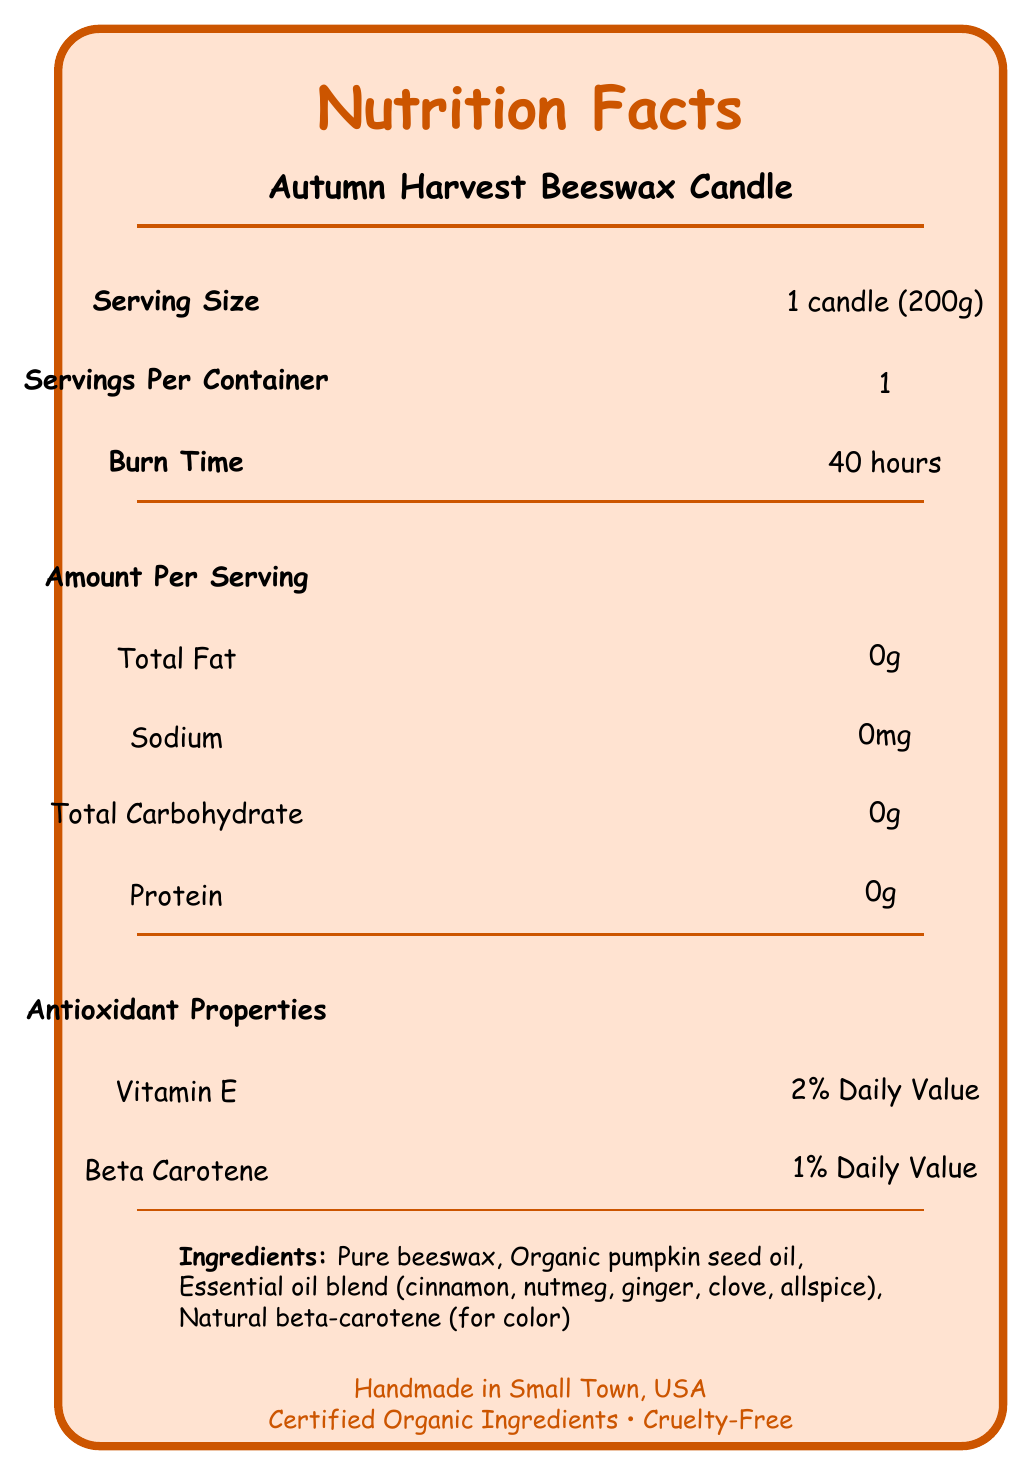What is the burn time of the Autumn Harvest Beeswax Candle? The document explicitly mentions the burn time as 40 hours in the section under Burn Time.
Answer: 40 hours How many servings are there per container? The document clearly states "Servings Per Container: 1."
Answer: 1 List the ingredients of the Autumn Harvest Beeswax Candle. The ingredients are listed at the bottom of the document under Ingredients.
Answer: Pure beeswax, Organic pumpkin seed oil, Essential oil blend (cinnamon, nutmeg, ginger, clove, allspice), Natural beta-carotene (for color) Which antioxidants are present in this candle, and what are their daily values? The Antioxidant Properties section lists Vitamin E and Beta Carotene with their respective daily values.
Answer: Vitamin E: 2% Daily Value, Beta Carotene: 1% Daily Value Does the candle contain any proteins? The Amount Per Serving section lists the protein content as 0g.
Answer: No What are the eco-friendly features of the candle? The features section mentions these specific eco-friendly attributes.
Answer: 100% natural ingredients, Biodegradable, Sustainably sourced beeswax Multiple-choice: What is the serving size?
A. 50g
B. 100g
C. 150g
D. 200g The Serving Size mentioned is "1 candle (200g)."
Answer: D Multiple-choice: Which of the following is not listed as an ingredient in the Autumn Harvest Beeswax Candle?
A. Cinnamon
B. Beeswax
C. Lavender
D. Nutmeg The ingredient list does not include Lavender; it lists Cinnamon, Beeswax, and Nutmeg.
Answer: C Yes/No: Is the candle certified organic? The document states that the candle contains Certified Organic Ingredients.
Answer: Yes Summary: Describe the main idea of the document. The document includes various sections such as Serving Size, Burn Time, Ingredients, Antioxidant Properties, and Certifications which give a comprehensive overview of the candle and its characteristics.
Answer: The document provides detailed information about the Autumn Harvest Beeswax Candle, including its ingredients, nutritional facts, antioxidant properties, eco-friendly features, usage instructions, and certifications. What are the aromatherapy benefits of the candle? The aromatherapy benefits are listed under the Aromatherapy Benefits section.
Answer: Stress relief, Mood enhancement, Improved focus What is the percentage of beta-carotene used as a natural colorant? The Natural Colorants section specifies "beta-carotene: 0.1%."
Answer: 0.1% What allergen information is given regarding this product? The Allergan Information section mentions the presence of nut oils and possible traces of almond oil.
Answer: Contains nut oils (may contain traces of almond oil from soap making process) Where is the candle handmade? The product origin is specified as "Handmade in Small Town, USA."
Answer: Small Town, USA Is there any information about the total revenue generated from this candle? The document does not include any information related to the revenue generated from the candle.
Answer: Cannot be determined 